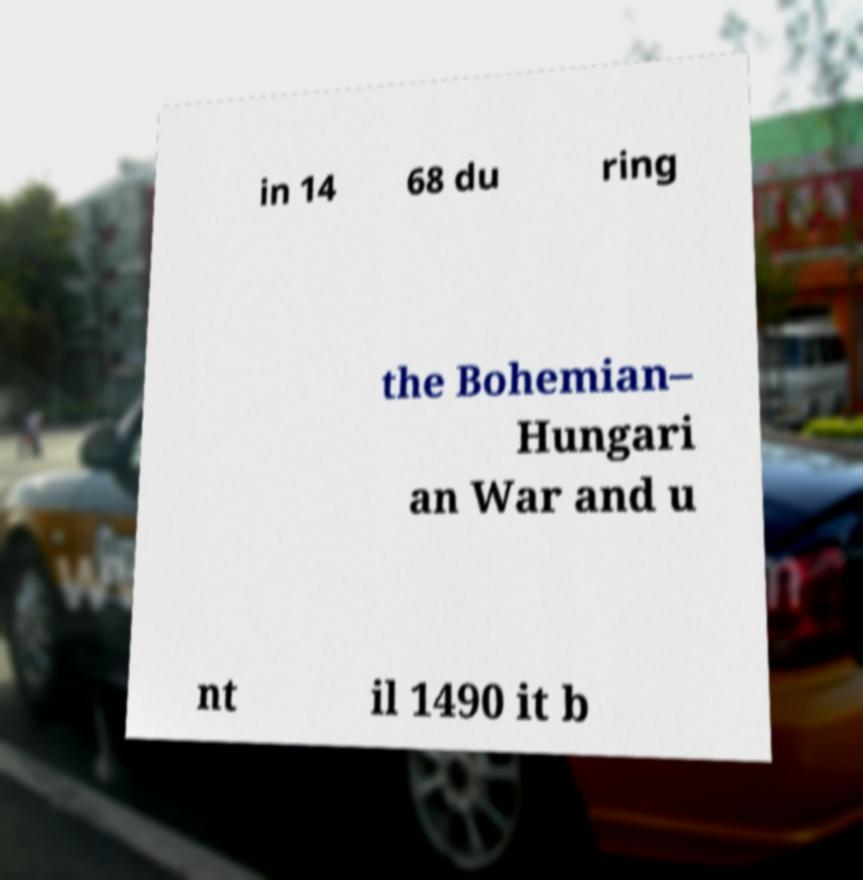Can you read and provide the text displayed in the image?This photo seems to have some interesting text. Can you extract and type it out for me? in 14 68 du ring the Bohemian– Hungari an War and u nt il 1490 it b 